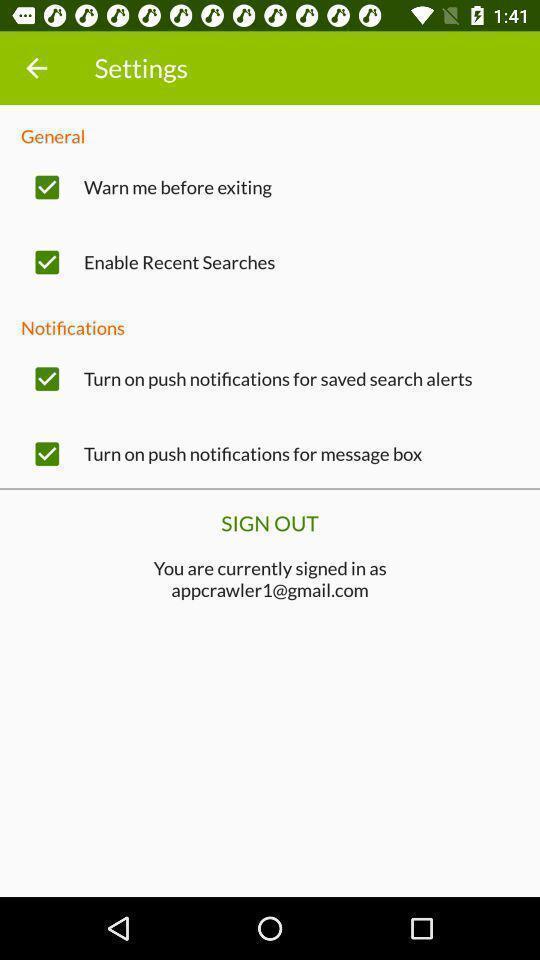Provide a textual representation of this image. Page showing the settings. 